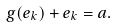Convert formula to latex. <formula><loc_0><loc_0><loc_500><loc_500>g ( e _ { k } ) + e _ { k } = a .</formula> 